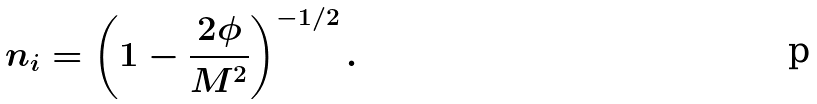<formula> <loc_0><loc_0><loc_500><loc_500>n _ { i } = \left ( 1 - \frac { 2 \phi } { M ^ { 2 } } \right ) ^ { - 1 / 2 } .</formula> 